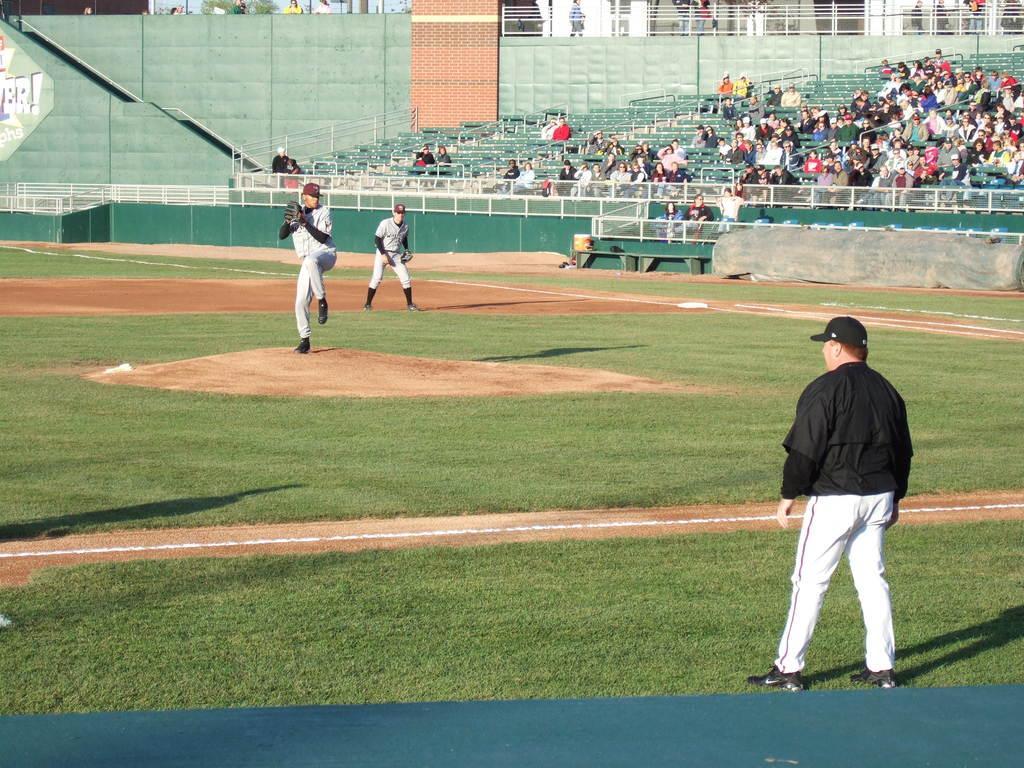How would you summarize this image in a sentence or two? In this image I can see a person wearing black and white colored dress is standing in the ground. In the background I can see two other persons are standing, the stadium, number of persons in the stadium, few trees, the railing, few persons standing and the sky. 